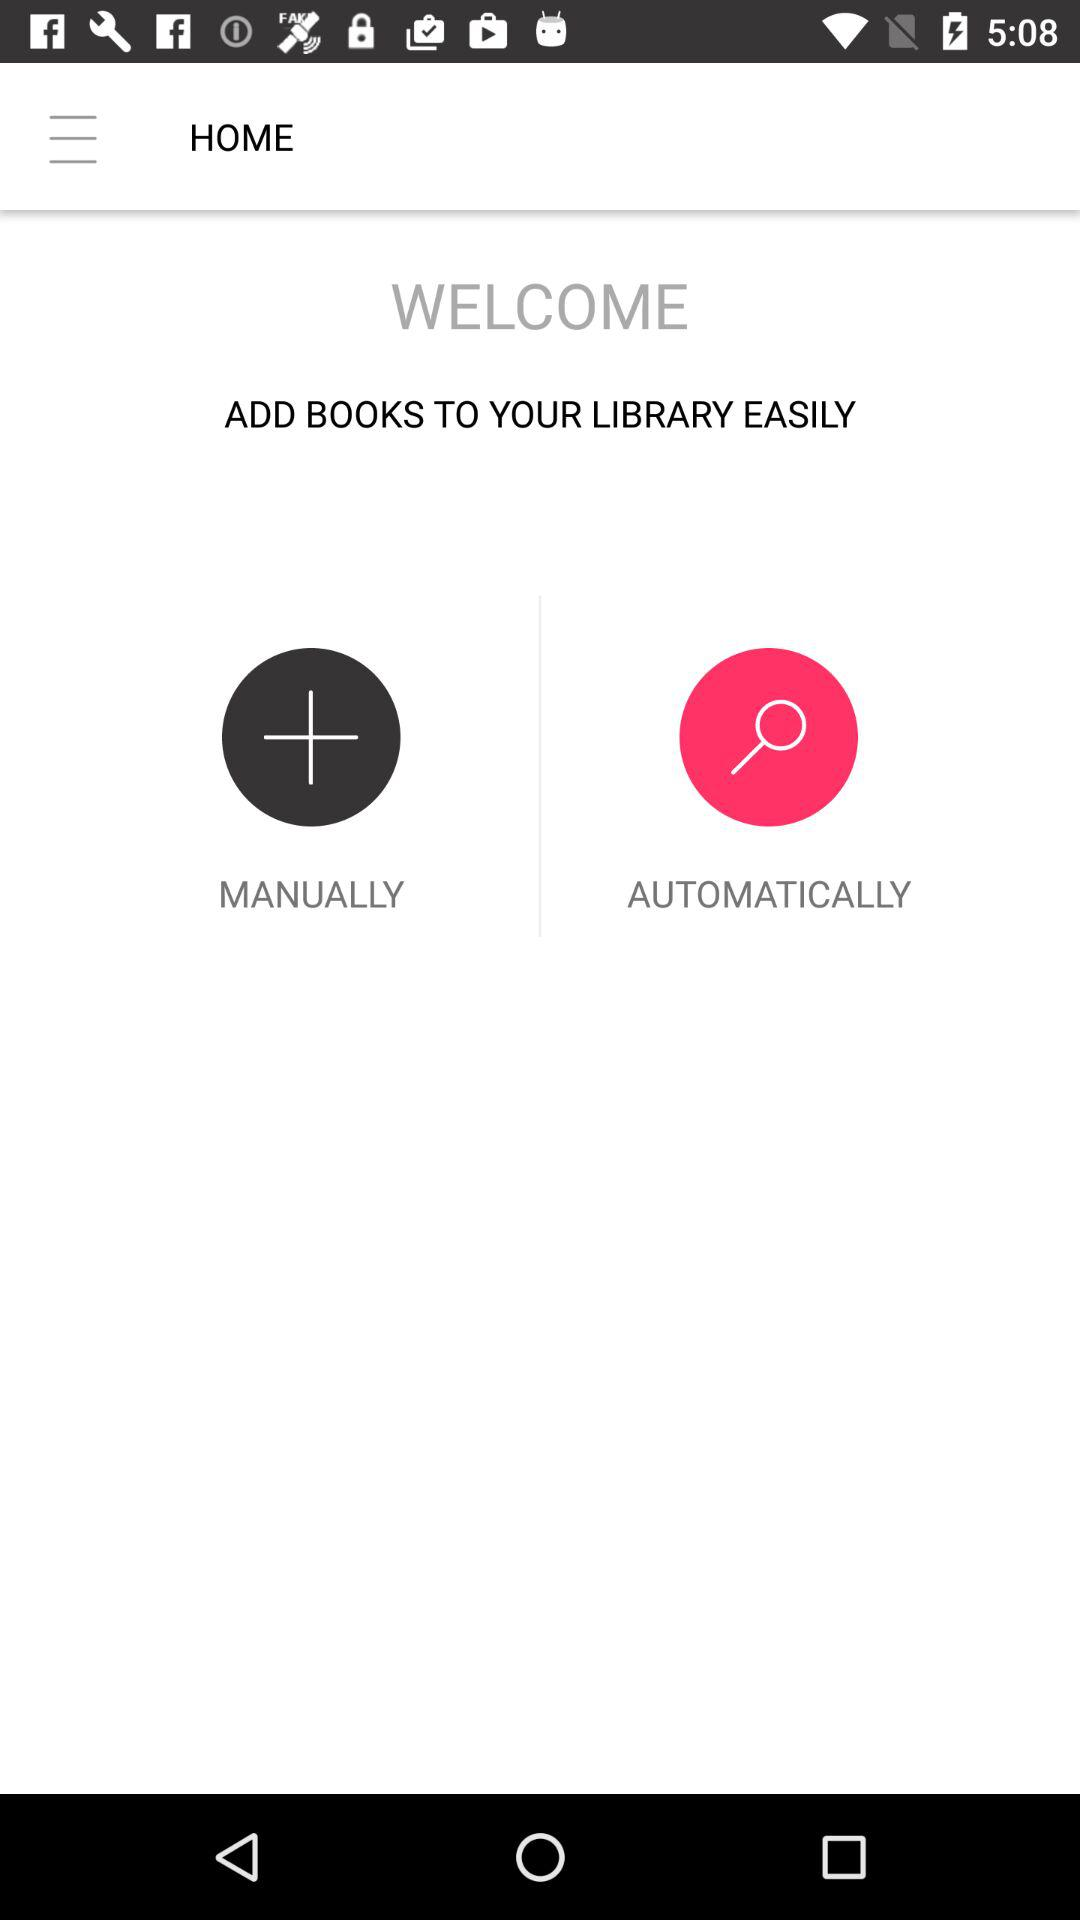How many ways are there to add books to your library?
Answer the question using a single word or phrase. 2 